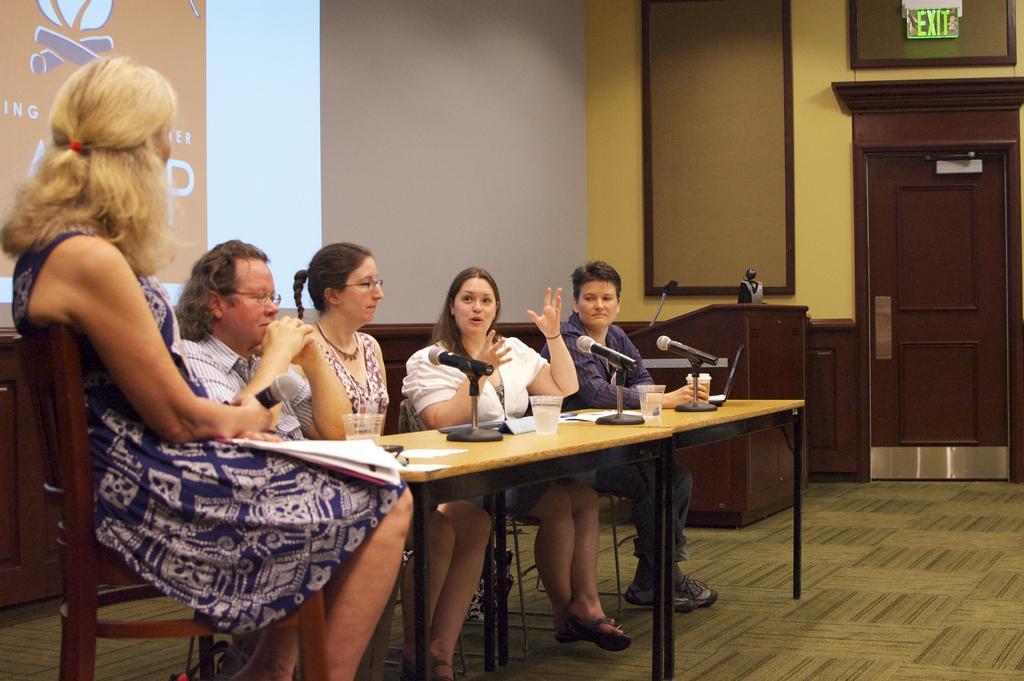Can you describe this image briefly? Her we can see a group of people are sitting on the chair, and in front here is the table and microphone and papers on it, and at back here is the wall, and here is the door. 